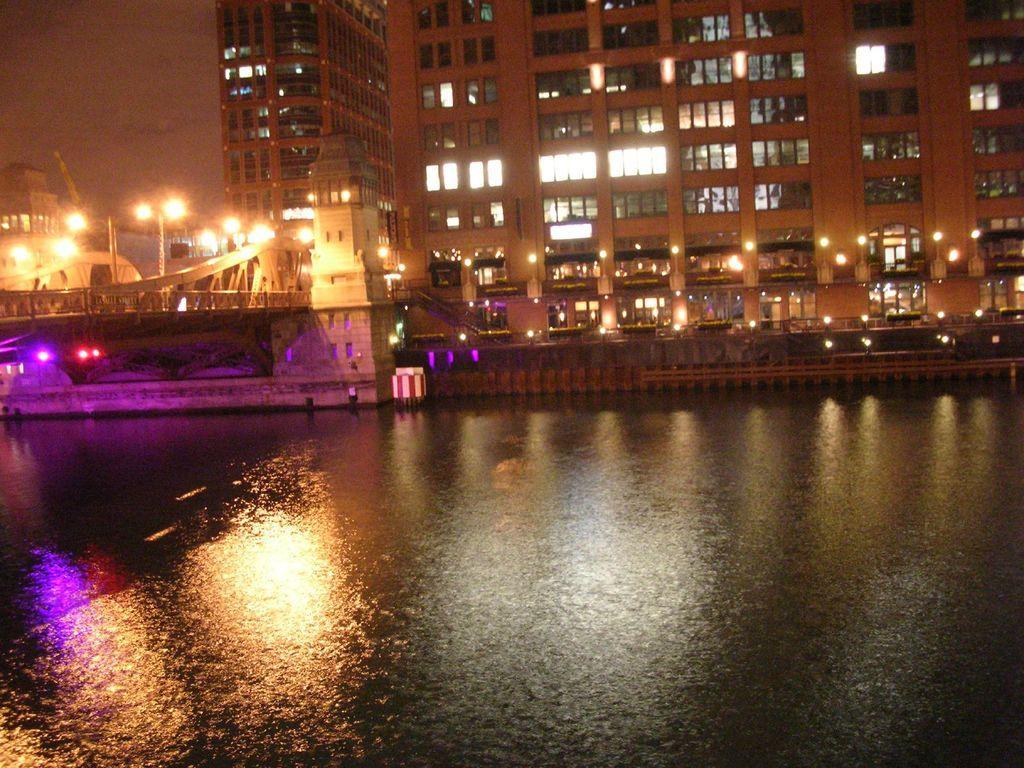Can you describe this image briefly? In this picture I can see water, there is a bridged, there are lights and buildings. 